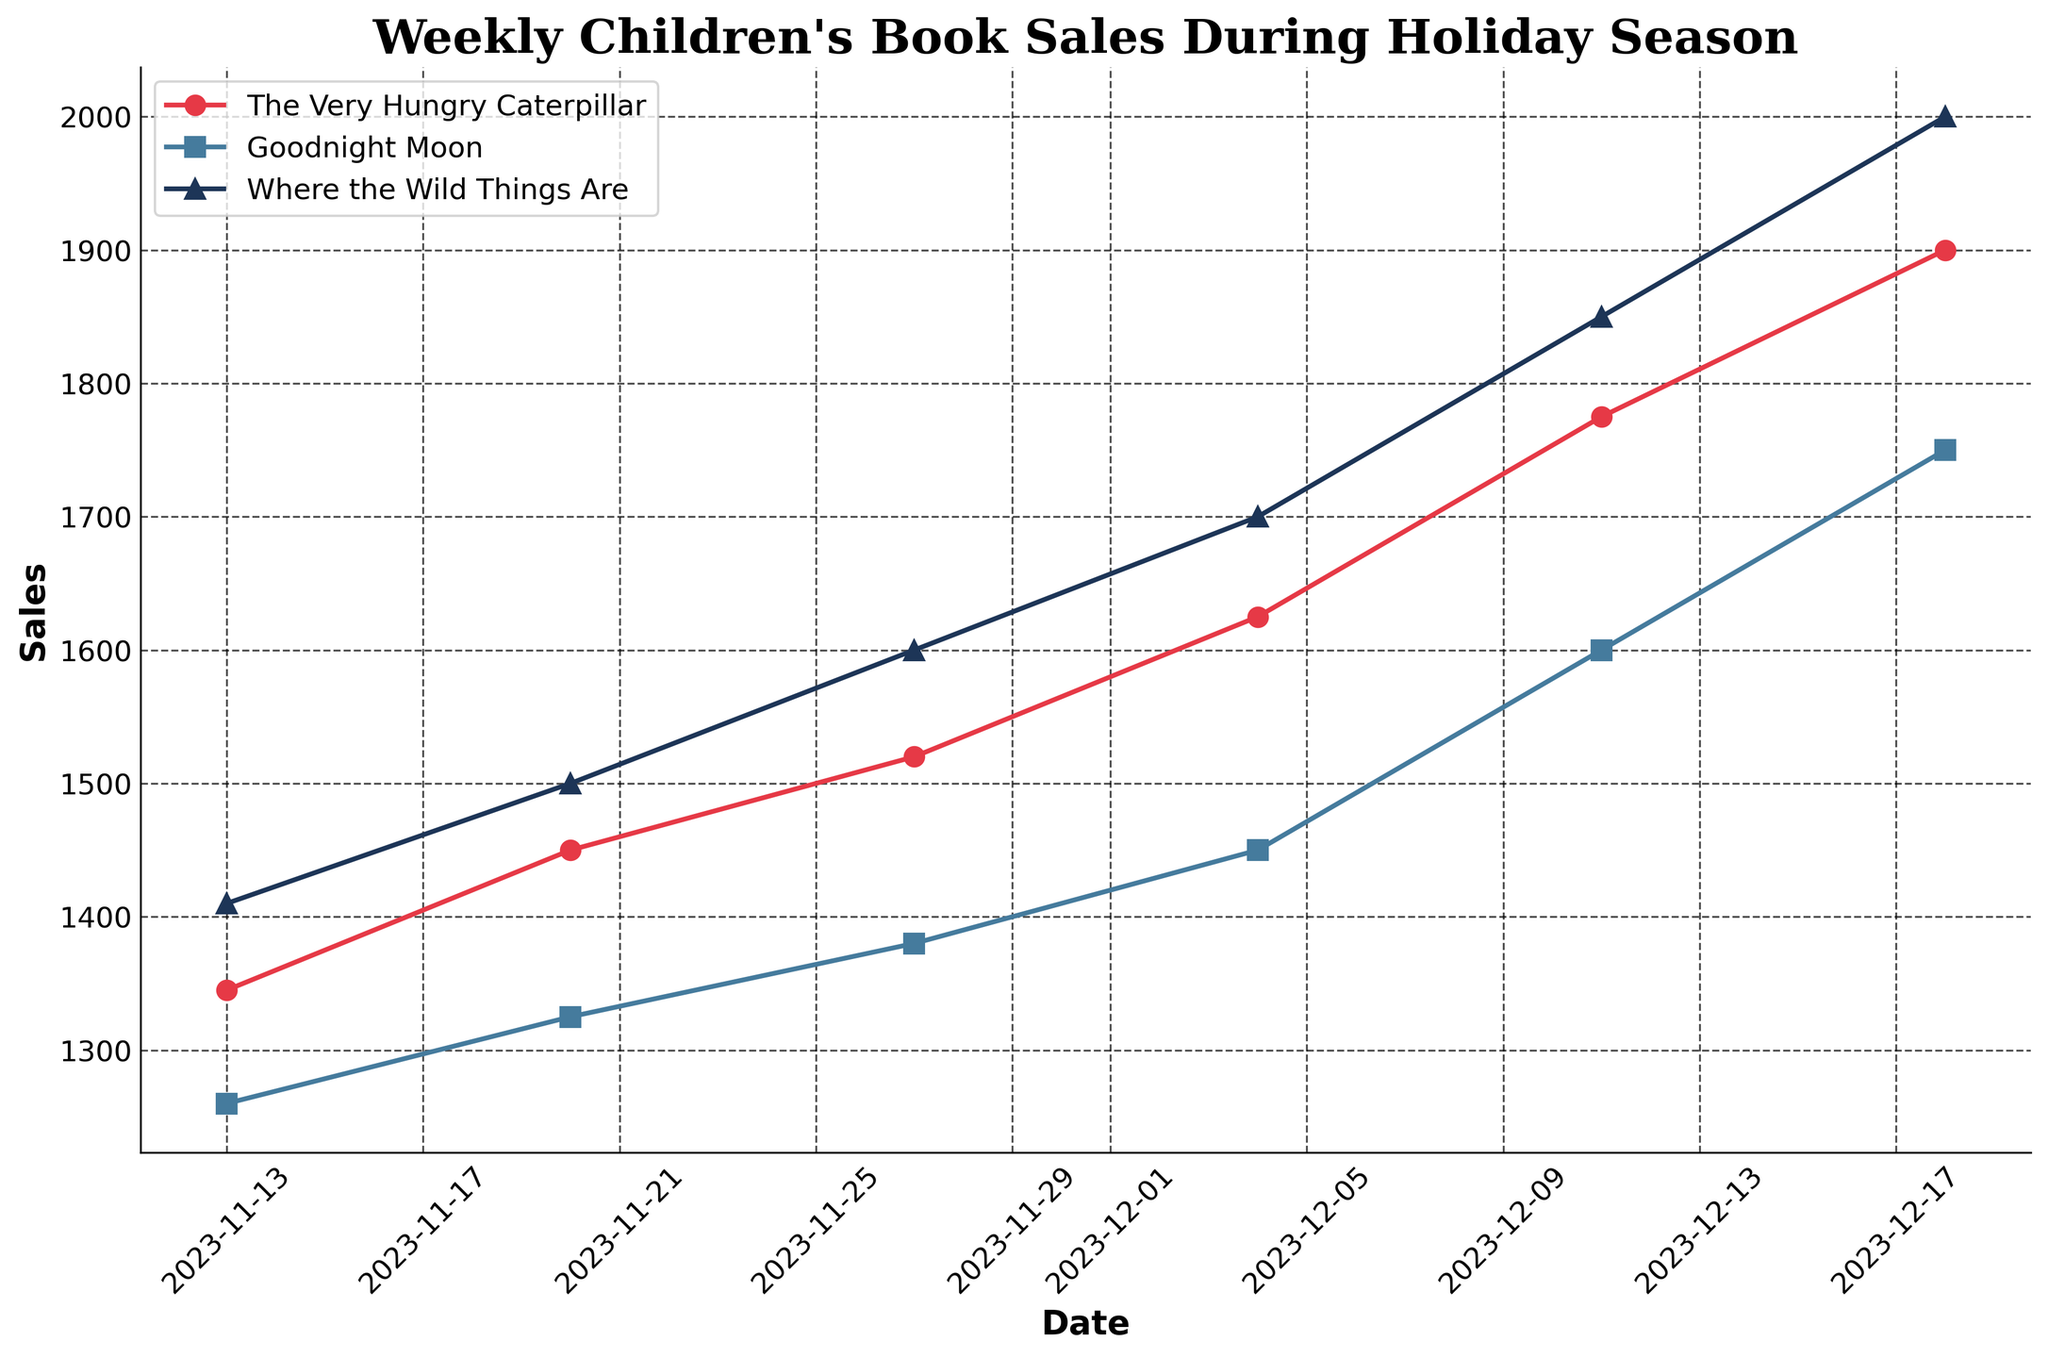What's the title of the plot? The title is prominently displayed at the top of the plot, which reads "Weekly Children's Book Sales During Holiday Season".
Answer: Weekly Children's Book Sales During Holiday Season What are the labels on the x and y axes? The x-axis label is "Date", and the y-axis label is "Sales". These are written near their respective axes.
Answer: Date and Sales How many unique dates are displayed on the plot? The plot shows dates along the x-axis. Identifying the unique dates can be done by counting them. The dates are 2023-11-13, 2023-11-20, 2023-11-27, 2023-12-04, 2023-12-11, and 2023-12-18.
Answer: 6 Which book had the highest sales on December 18, 2023? On Dec 18, 2023, the sales values for "The Very Hungry Caterpillar", "Goodnight Moon", and "Where the Wild Things Are" are plotted. By checking the highest point on this date, "Where the Wild Things Are" has the highest sales of 2000.
Answer: Where the Wild Things Are What is the sales trend for "Goodnight Moon" during the holiday season? To identify the sales trend, observe the sales points for "Goodnight Moon" over the dates. The sales numbers are increasing each week from 1260 to 1750, indicating an upward trend.
Answer: Increasing Which week shows the most significant increase in sales for "The Very Hungry Caterpillar"? Comparing week-to-week sales values for "The Very Hungry Caterpillar" helps determine the increase. The weeks are: 1345 to 1450, 1450 to 1520, 1520 to 1625, 1625 to 1775, 1775 to 1900. The largest increase is from 1625 to 1775.
Answer: Dec 04 to Dec 11 Compare the sales of all three books on November 27, 2023. Which book had the lowest sales, and which had the highest sales? On Nov 27, "The Very Hungry Caterpillar" has 1520 sales, "Goodnight Moon" has 1380 sales, and "Where the Wild Things Are" has 1600 sales. The book with the lowest sales is "Goodnight Moon", and the highest is "Where the Wild Things Are".
Answer: Goodnight Moon (lowest), Where the Wild Things Are (highest) What is the pattern of sales for "The Very Hungry Caterpillar" from the beginning to the end of the time period? Examining the sales data for "The Very Hungry Caterpillar" from 2023-11-13 to 2023-12-18, the sales values show a consistent increase each week: 1345, 1450, 1520, 1625, 1775, 1900. This indicates a steadily increasing pattern.
Answer: Steadily increasing Are there any weeks where all three books show an increase in sales compared to the previous week? By comparing week-to-week sales, note: From 11-13 to 11-20 (all increase), 11-20 to 11-27 (all increase), 11-27 to 12-04 (all increase), 12-04 to 12-11 (all increase), 12-11 to 12-18 (all increase). All weeks show simultaneous increases.
Answer: Yes, every week Which book had the highest total sales over the entire period? To find the book with the highest total sales, sum the sales of each book over all dates:
- "The Very Hungry Caterpillar": 1345+1450+1520+1625+1775+1900 = 9615.
- "Goodnight Moon": 1260+1325+1380+1450+1600+1750 = 8765.
- "Where the Wild Things Are": 1410+1500+1600+1700+1850+2000 = 10060.
"Where the Wild Things Are" has the highest total sales.
Answer: Where the Wild Things Are 